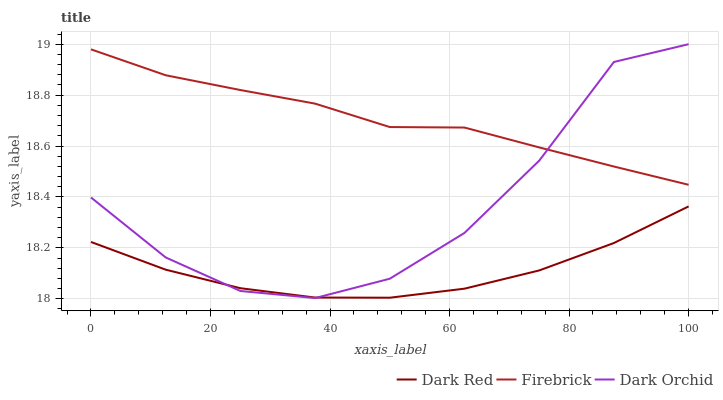Does Dark Red have the minimum area under the curve?
Answer yes or no. Yes. Does Firebrick have the maximum area under the curve?
Answer yes or no. Yes. Does Dark Orchid have the minimum area under the curve?
Answer yes or no. No. Does Dark Orchid have the maximum area under the curve?
Answer yes or no. No. Is Dark Red the smoothest?
Answer yes or no. Yes. Is Dark Orchid the roughest?
Answer yes or no. Yes. Is Firebrick the smoothest?
Answer yes or no. No. Is Firebrick the roughest?
Answer yes or no. No. Does Dark Orchid have the lowest value?
Answer yes or no. Yes. Does Firebrick have the lowest value?
Answer yes or no. No. Does Dark Orchid have the highest value?
Answer yes or no. Yes. Does Firebrick have the highest value?
Answer yes or no. No. Is Dark Red less than Firebrick?
Answer yes or no. Yes. Is Firebrick greater than Dark Red?
Answer yes or no. Yes. Does Dark Orchid intersect Dark Red?
Answer yes or no. Yes. Is Dark Orchid less than Dark Red?
Answer yes or no. No. Is Dark Orchid greater than Dark Red?
Answer yes or no. No. Does Dark Red intersect Firebrick?
Answer yes or no. No. 